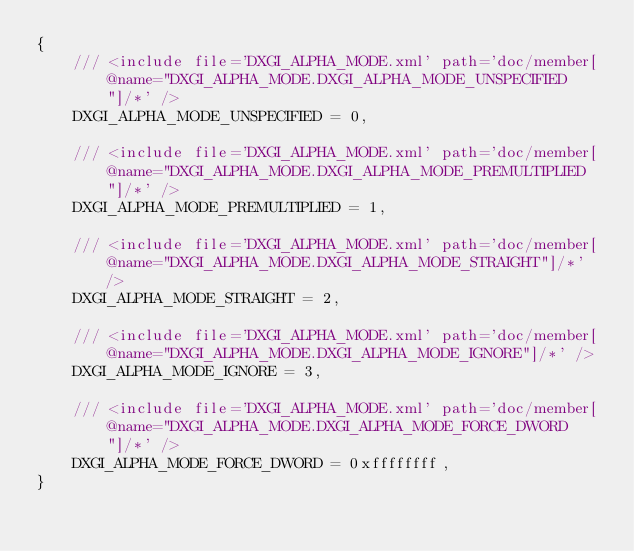<code> <loc_0><loc_0><loc_500><loc_500><_C#_>{
    /// <include file='DXGI_ALPHA_MODE.xml' path='doc/member[@name="DXGI_ALPHA_MODE.DXGI_ALPHA_MODE_UNSPECIFIED"]/*' />
    DXGI_ALPHA_MODE_UNSPECIFIED = 0,

    /// <include file='DXGI_ALPHA_MODE.xml' path='doc/member[@name="DXGI_ALPHA_MODE.DXGI_ALPHA_MODE_PREMULTIPLIED"]/*' />
    DXGI_ALPHA_MODE_PREMULTIPLIED = 1,

    /// <include file='DXGI_ALPHA_MODE.xml' path='doc/member[@name="DXGI_ALPHA_MODE.DXGI_ALPHA_MODE_STRAIGHT"]/*' />
    DXGI_ALPHA_MODE_STRAIGHT = 2,

    /// <include file='DXGI_ALPHA_MODE.xml' path='doc/member[@name="DXGI_ALPHA_MODE.DXGI_ALPHA_MODE_IGNORE"]/*' />
    DXGI_ALPHA_MODE_IGNORE = 3,

    /// <include file='DXGI_ALPHA_MODE.xml' path='doc/member[@name="DXGI_ALPHA_MODE.DXGI_ALPHA_MODE_FORCE_DWORD"]/*' />
    DXGI_ALPHA_MODE_FORCE_DWORD = 0xffffffff,
}
</code> 